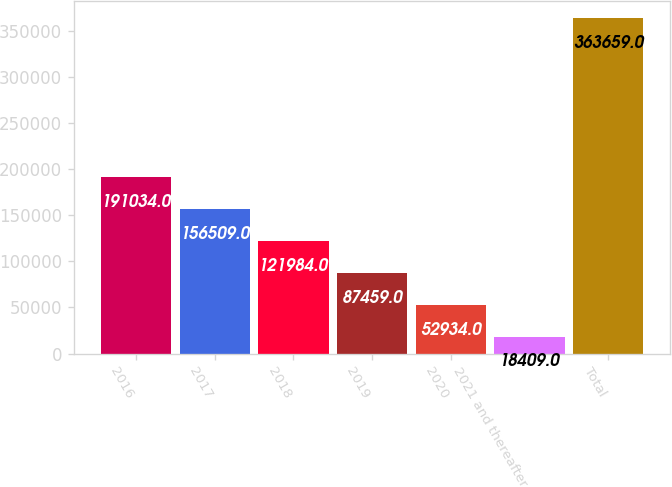Convert chart to OTSL. <chart><loc_0><loc_0><loc_500><loc_500><bar_chart><fcel>2016<fcel>2017<fcel>2018<fcel>2019<fcel>2020<fcel>2021 and thereafter<fcel>Total<nl><fcel>191034<fcel>156509<fcel>121984<fcel>87459<fcel>52934<fcel>18409<fcel>363659<nl></chart> 